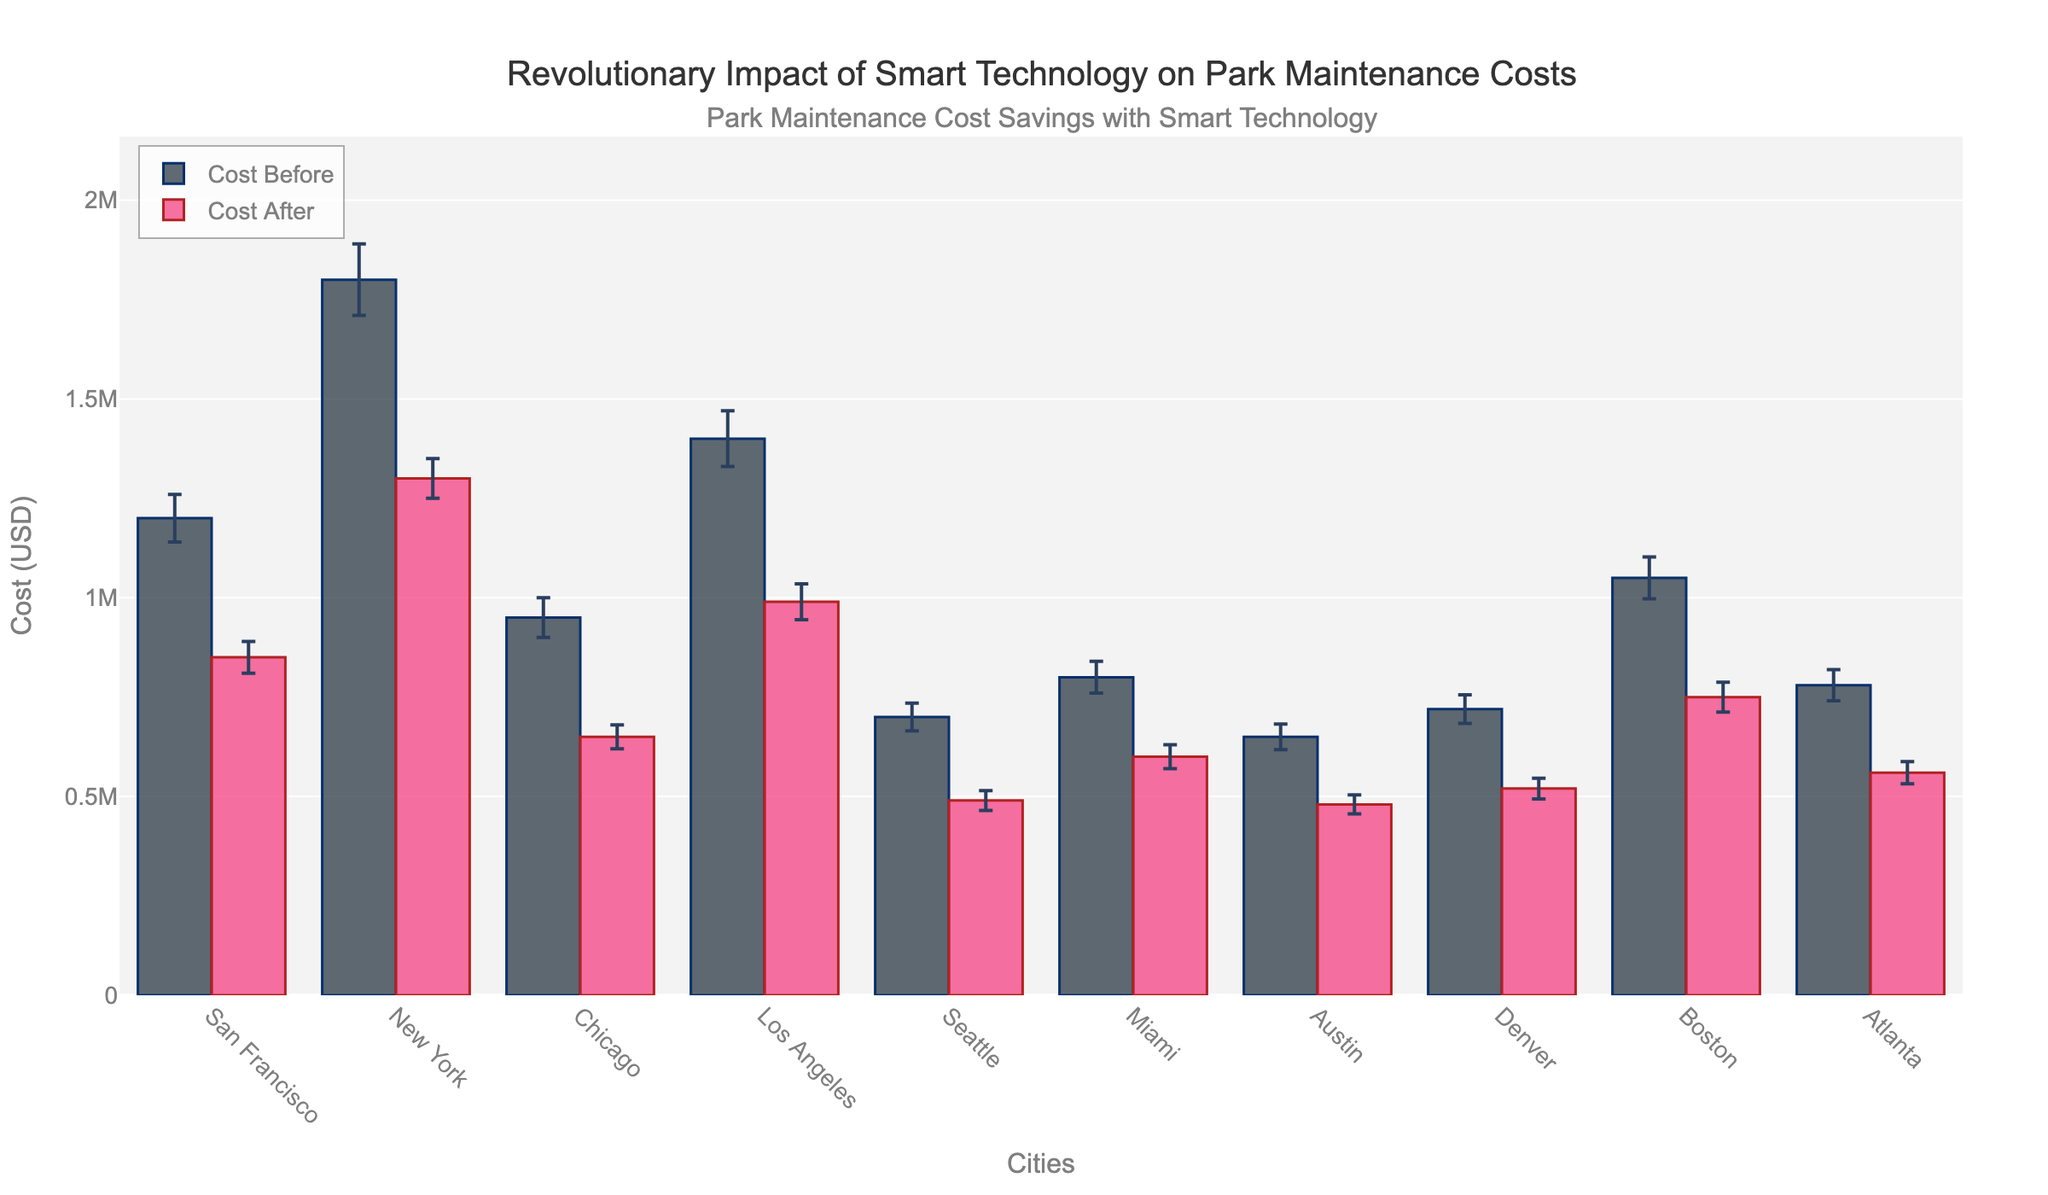What is the title of the figure? The title is at the top of the figure, annotated with larger and bold text.
Answer: Revolutionary Impact of Smart Technology on Park Maintenance Costs How many cities are represented in the bar chart? Each bar on the x-axis represents a city. Count the number of unique city names. There are 10 cities listed.
Answer: 10 Which city had the highest cost savings after implementing smart technology? The cost savings can be determined by the difference between 'Cost Before' and 'Cost After' for each city. The city with the largest difference is New York (1800000 - 1300000 = 500000).
Answer: New York What are the colors used for 'Cost Before' and 'Cost After' bars? The colors of the bars are visually distinguishable. The 'Cost Before' bars are a dark shade (grayish) and the 'Cost After' bars are a bright shade (pinkish).
Answer: Dark gray (Cost Before) and pink (Cost After) What is the range of the y-axis? Look at the y-axis from bottom to top. The range is from 0 to the highest value which is approximately 1,200,000 USD.
Answer: 0 to 1,200,000 USD Which city had the smallest error margin for the cost after implementing smart technology? The error margin after implementing smart technology is shown with error bars. The city with the smallest error bar for the 'Cost After' is Austin (24,000 USD).
Answer: Austin What was the average cost before implementing smart technology across all cities? Sum all 'Cost Before' values and divide by the number of cities. (1200000+1800000+950000+1400000+700000+800000+650000+720000+1050000+780000)/10 = 1,020,000 USD.
Answer: 1,020,000 USD Which city had the highest cost before implementing smart technology? The highest 'Cost Before' bar will represent the city. New York's bar at 1,800,000 USD is the highest.
Answer: New York By how much did the cost decrease in Denver after implementing smart technology? The cost decrease is the difference between 'Cost Before' and 'Cost After'. Denver's cost decreased from 720,000 USD to 520,000 USD. 720000 - 520000 = 200000 USD.
Answer: 200000 USD Is there any city where the error margin is smaller for 'Cost Before' than for 'Cost After'? Compare the error margins of 'Cost Before' and 'Cost After' for each city. No city has a smaller error margin for 'Cost Before' than 'Cost After' according to the figure.
Answer: No 